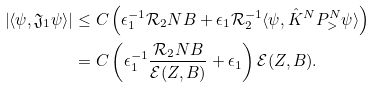Convert formula to latex. <formula><loc_0><loc_0><loc_500><loc_500>\left | \langle \psi , { \mathfrak J } _ { 1 } \psi \rangle \right | & \leq C \left ( \epsilon _ { 1 } ^ { - 1 } { \mathcal { R } } _ { 2 } N B + \epsilon _ { 1 } { \mathcal { R } } _ { 2 } ^ { - 1 } \langle \psi , \hat { K } ^ { N } P _ { > } ^ { N } \psi \rangle \right ) \\ & = C \left ( \epsilon _ { 1 } ^ { - 1 } \frac { { \mathcal { R } } _ { 2 } N B } { { \mathcal { E } } ( Z , B ) } + \epsilon _ { 1 } \right ) { \mathcal { E } } ( Z , B ) .</formula> 